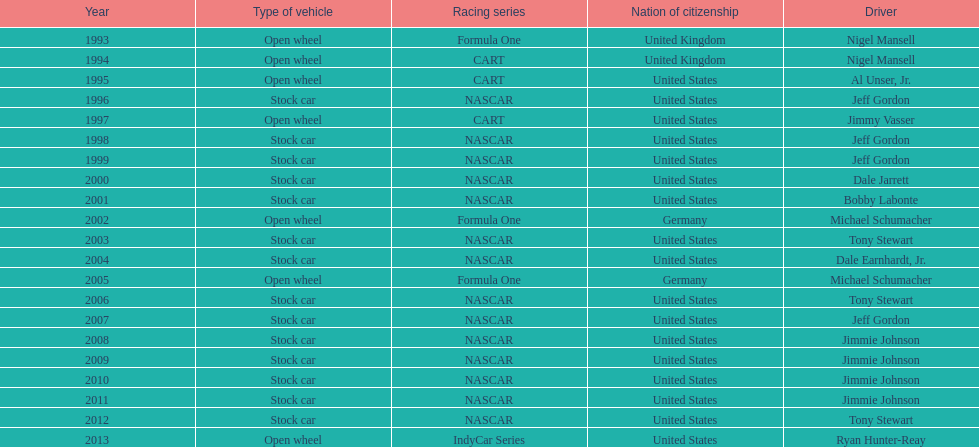Does the united states have more nation of citzenship then united kingdom? Yes. 